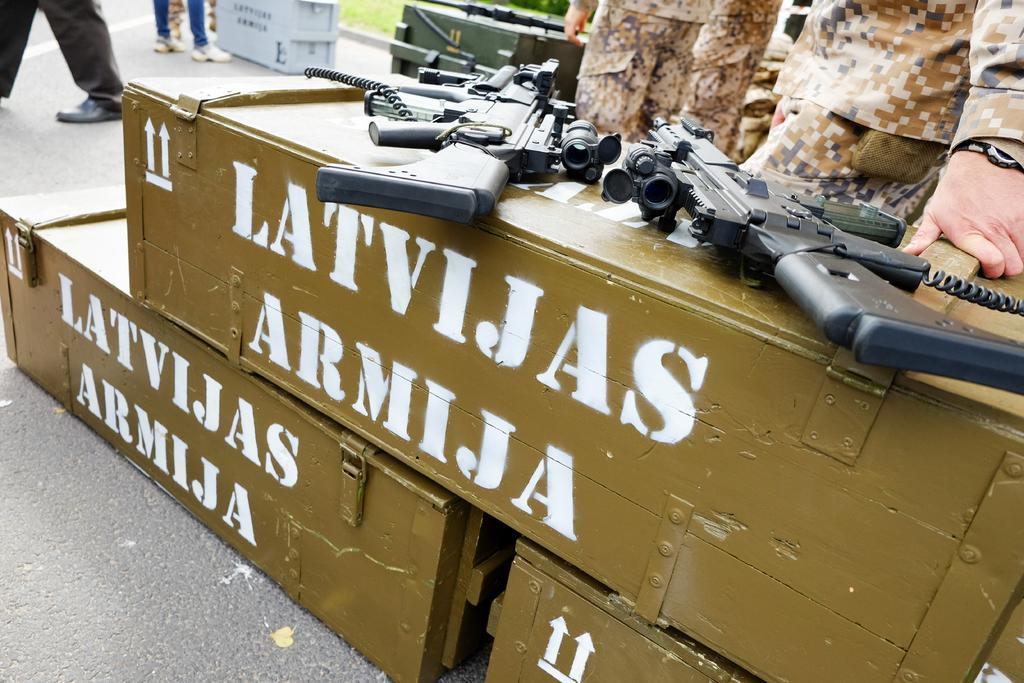What objects are in the foreground of the image? There are three boxes in the foreground of the image. What is placed on the boxes? Two guns are placed on the boxes. What can be seen in the background of the image? There are persons standing and additional boxes in the background of the image. Are the guns visible in the background as well? Yes, the guns are also visible in the background of the image. What type of apple can be seen in the image, and how does it taste? There is no apple present in the image, so it cannot be determined what type it is or how it tastes. 